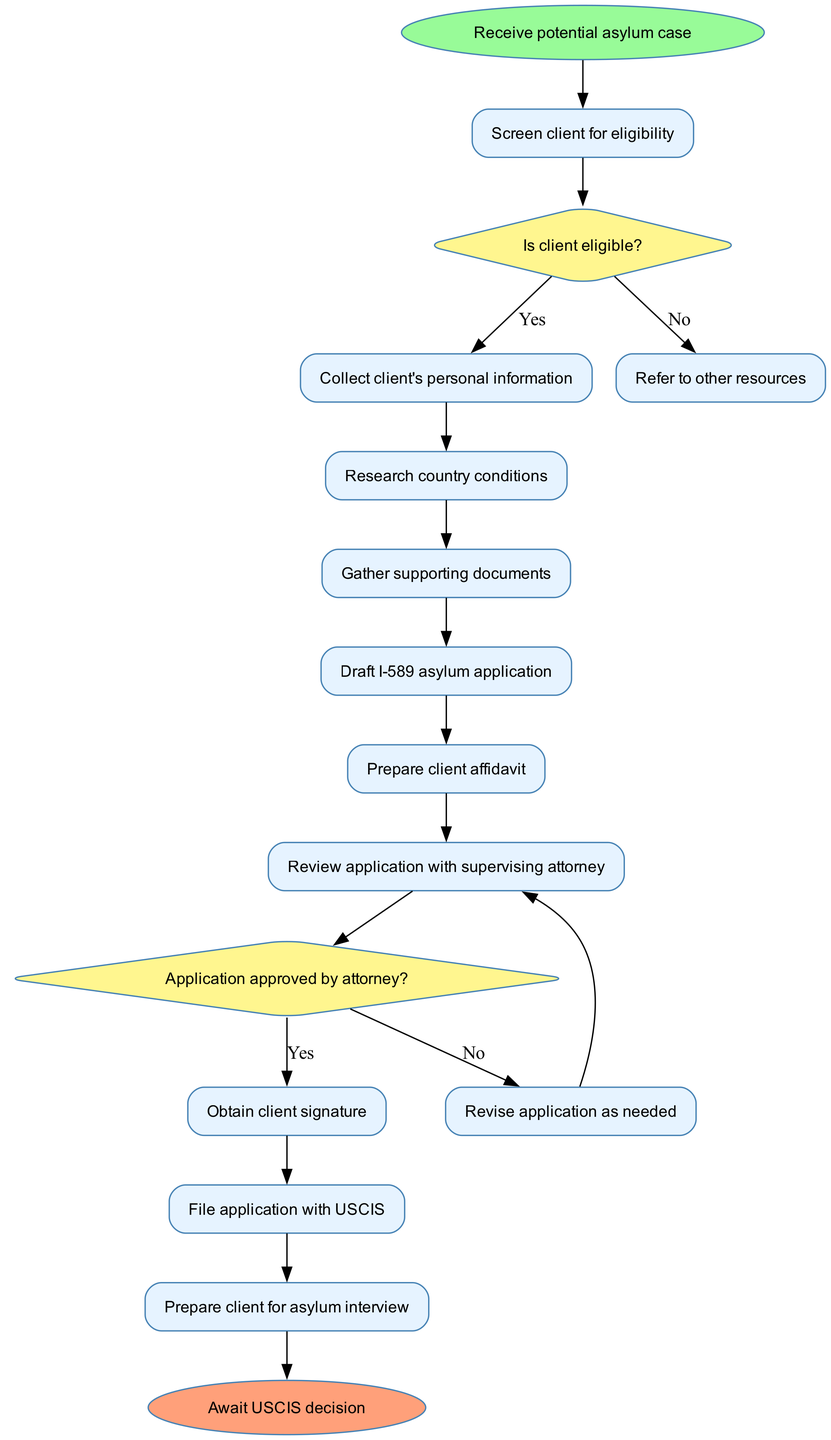What is the first activity in the workflow? The diagram starts with the node labeled "Receive potential asylum case," indicating it is the first activity in this workflow.
Answer: Receive potential asylum case How many activities are there in the workflow? By counting the list of activities provided in the diagram, there are a total of 10 distinct activities.
Answer: 10 What happens if the client is not eligible? According to the decision labeled "Is client eligible?" if the answer is "No," the workflow directs to "Refer to other resources."
Answer: Refer to other resources What is the last step before filing the application? The final activity before filing the application is "Obtain client signature," as depicted directly before the "File application with USCIS" activity.
Answer: Obtain client signature Which activity follows the "Review application with supervising attorney"? After reviewing the application, if there are any issues, the workflow directs to "Revise application as needed," indicating this is the subsequent activity.
Answer: Revise application as needed What decision is made after the attorney reviews the application? The diagram specifies that after reviewing the application, the decision is whether the "Application approved by attorney?" If "Yes," the flow continues to obtain the client signature; if "No," it revises the application.
Answer: Application approved by attorney? What is the end point of this workflow? The last node in the diagram is labeled "Await USCIS decision," indicating that this is the endpoint of the pro bono asylum application workflow.
Answer: Await USCIS decision What is the purpose of the "Prepare client for asylum interview" activity? This activity occurs at the end of the workflow and prepares the client for the asylum interview, indicating it is an essential step in the process after filing.
Answer: Prepare client for asylum interview 